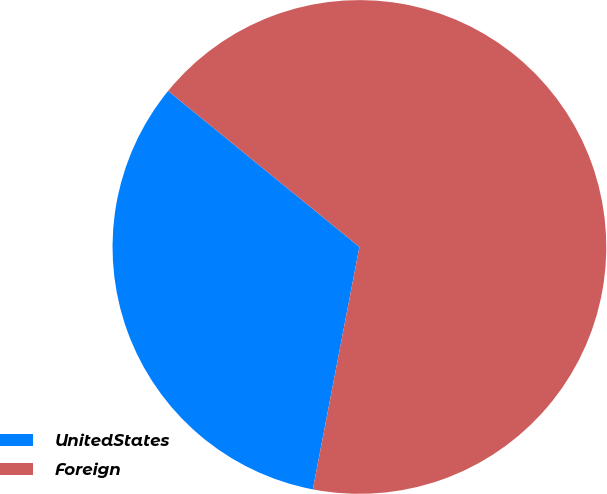Convert chart to OTSL. <chart><loc_0><loc_0><loc_500><loc_500><pie_chart><fcel>UnitedStates<fcel>Foreign<nl><fcel>32.87%<fcel>67.13%<nl></chart> 